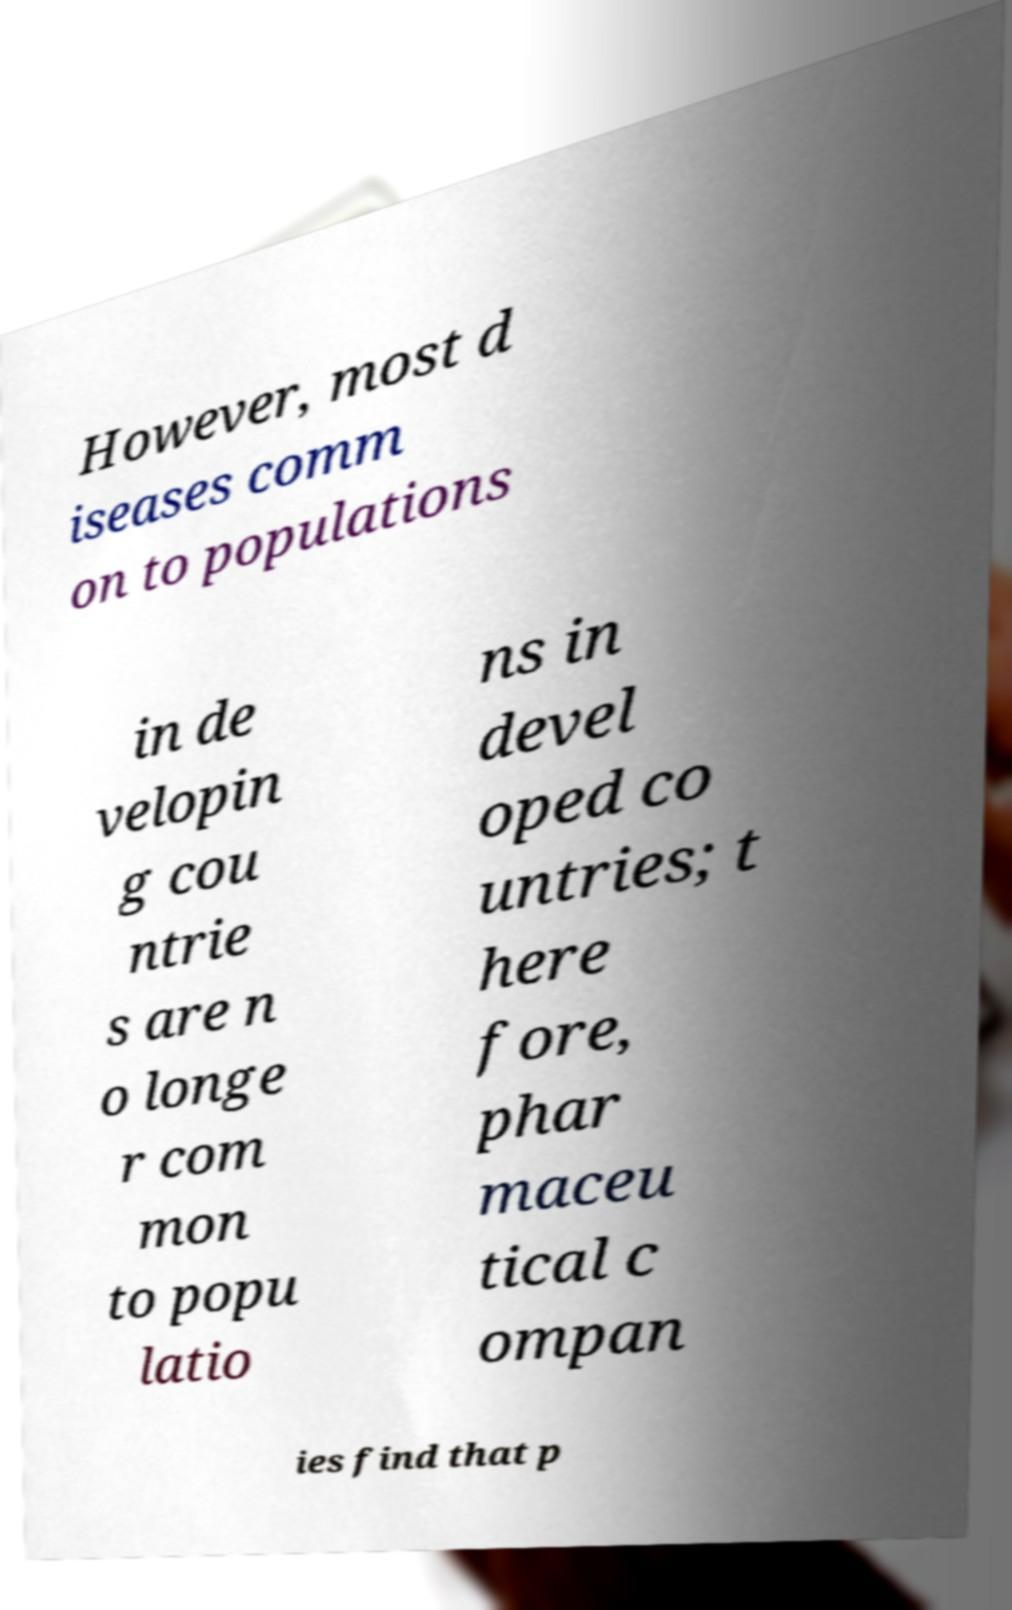What messages or text are displayed in this image? I need them in a readable, typed format. However, most d iseases comm on to populations in de velopin g cou ntrie s are n o longe r com mon to popu latio ns in devel oped co untries; t here fore, phar maceu tical c ompan ies find that p 